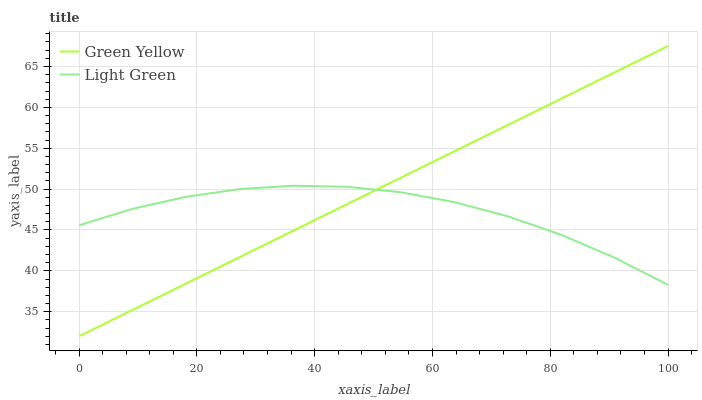Does Light Green have the minimum area under the curve?
Answer yes or no. Yes. Does Green Yellow have the maximum area under the curve?
Answer yes or no. Yes. Does Light Green have the maximum area under the curve?
Answer yes or no. No. Is Green Yellow the smoothest?
Answer yes or no. Yes. Is Light Green the roughest?
Answer yes or no. Yes. Is Light Green the smoothest?
Answer yes or no. No. Does Green Yellow have the lowest value?
Answer yes or no. Yes. Does Light Green have the lowest value?
Answer yes or no. No. Does Green Yellow have the highest value?
Answer yes or no. Yes. Does Light Green have the highest value?
Answer yes or no. No. Does Light Green intersect Green Yellow?
Answer yes or no. Yes. Is Light Green less than Green Yellow?
Answer yes or no. No. Is Light Green greater than Green Yellow?
Answer yes or no. No. 